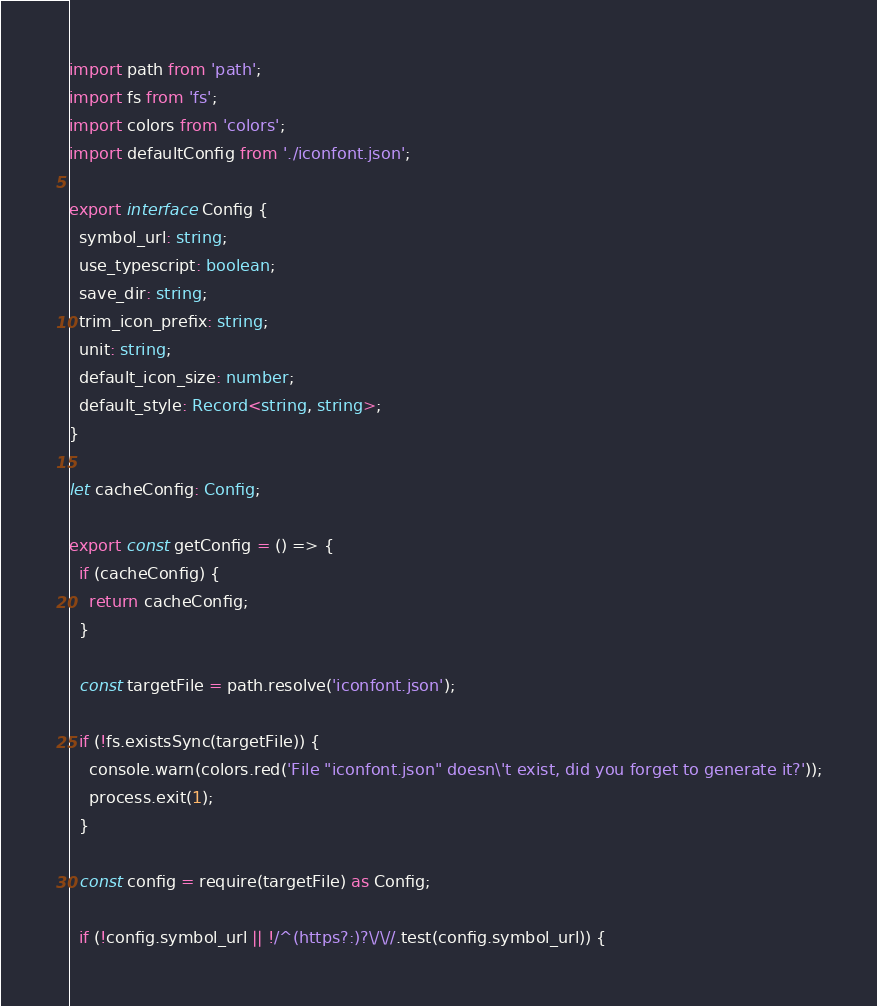<code> <loc_0><loc_0><loc_500><loc_500><_TypeScript_>import path from 'path';
import fs from 'fs';
import colors from 'colors';
import defaultConfig from './iconfont.json';

export interface Config {
  symbol_url: string;
  use_typescript: boolean;
  save_dir: string;
  trim_icon_prefix: string;
  unit: string;
  default_icon_size: number;
  default_style: Record<string, string>;
}

let cacheConfig: Config;

export const getConfig = () => {
  if (cacheConfig) {
    return cacheConfig;
  }

  const targetFile = path.resolve('iconfont.json');

  if (!fs.existsSync(targetFile)) {
    console.warn(colors.red('File "iconfont.json" doesn\'t exist, did you forget to generate it?'));
    process.exit(1);
  }

  const config = require(targetFile) as Config;

  if (!config.symbol_url || !/^(https?:)?\/\//.test(config.symbol_url)) {</code> 